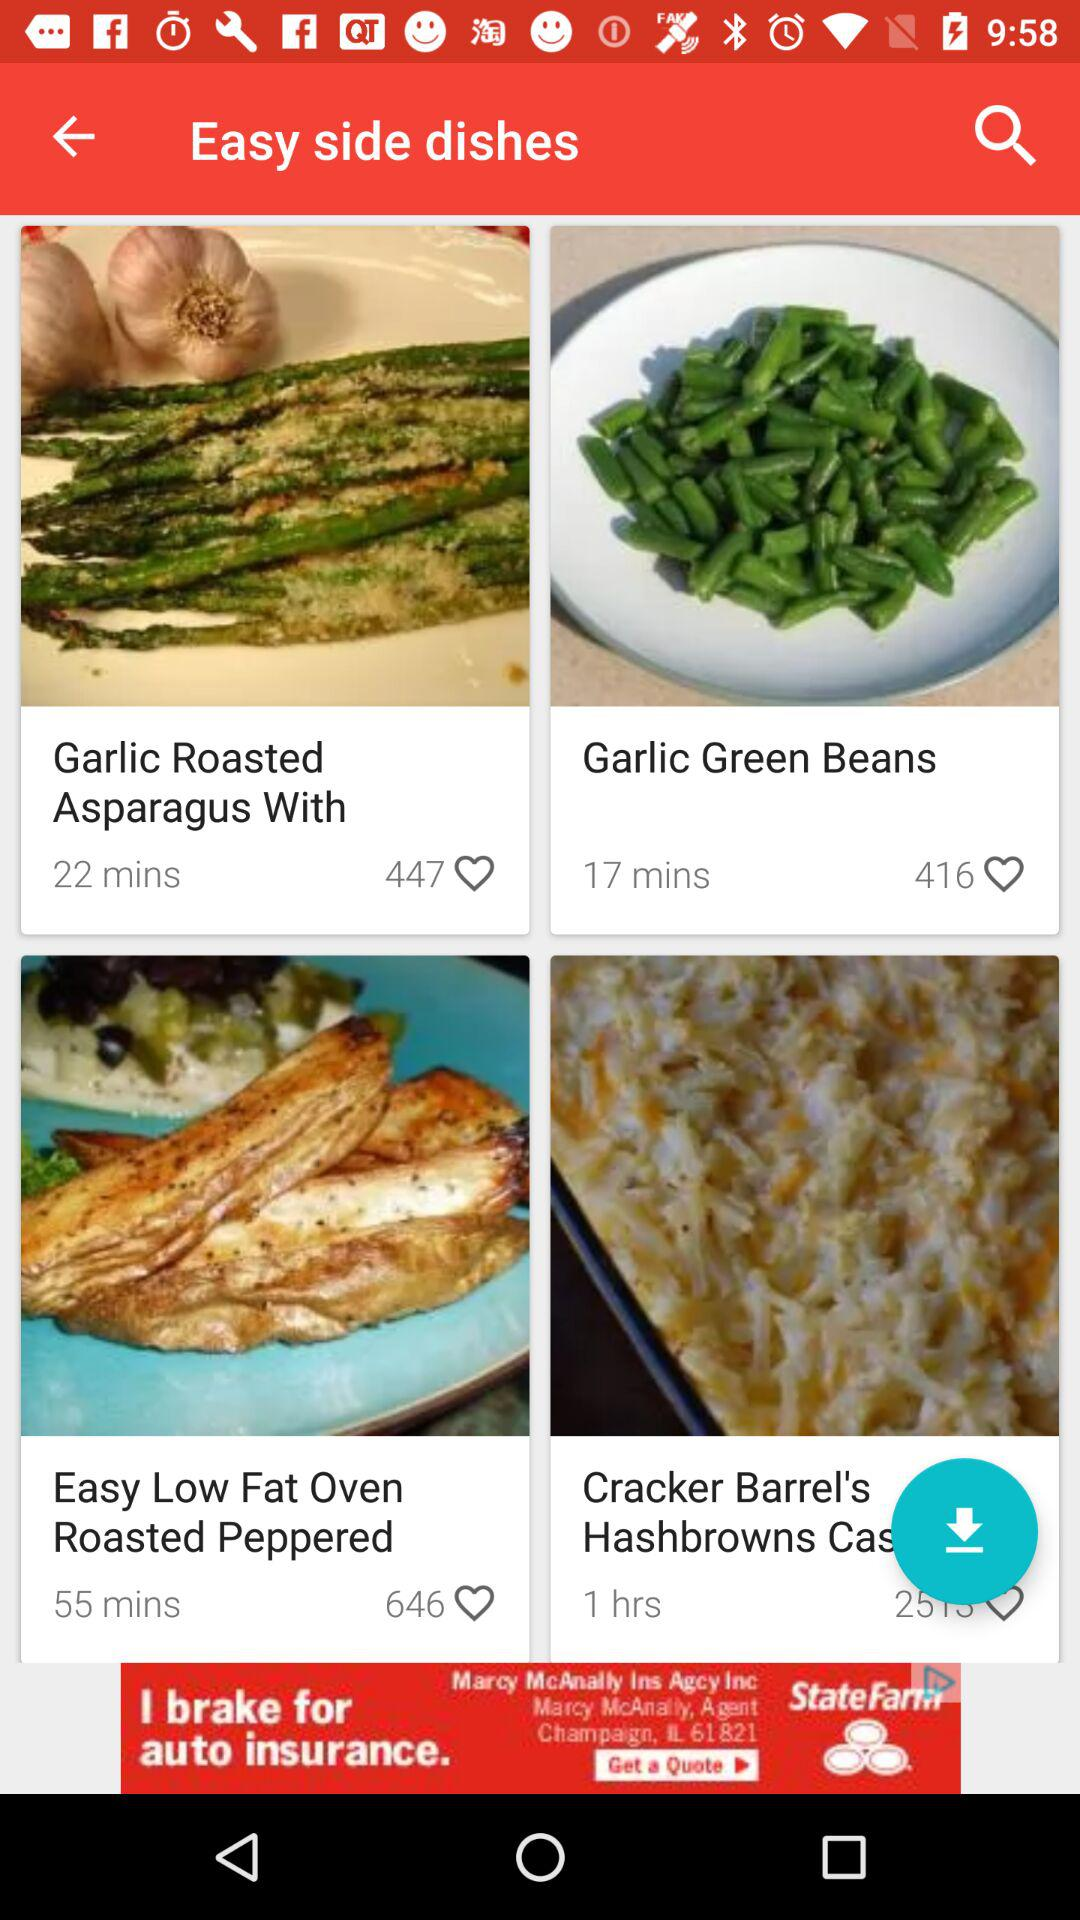Which dish has a cooking duration of 55 minutes? The dish that has a cooking duration of 55 minutes is "Easy Low Fat Oven Roasted Peppered". 